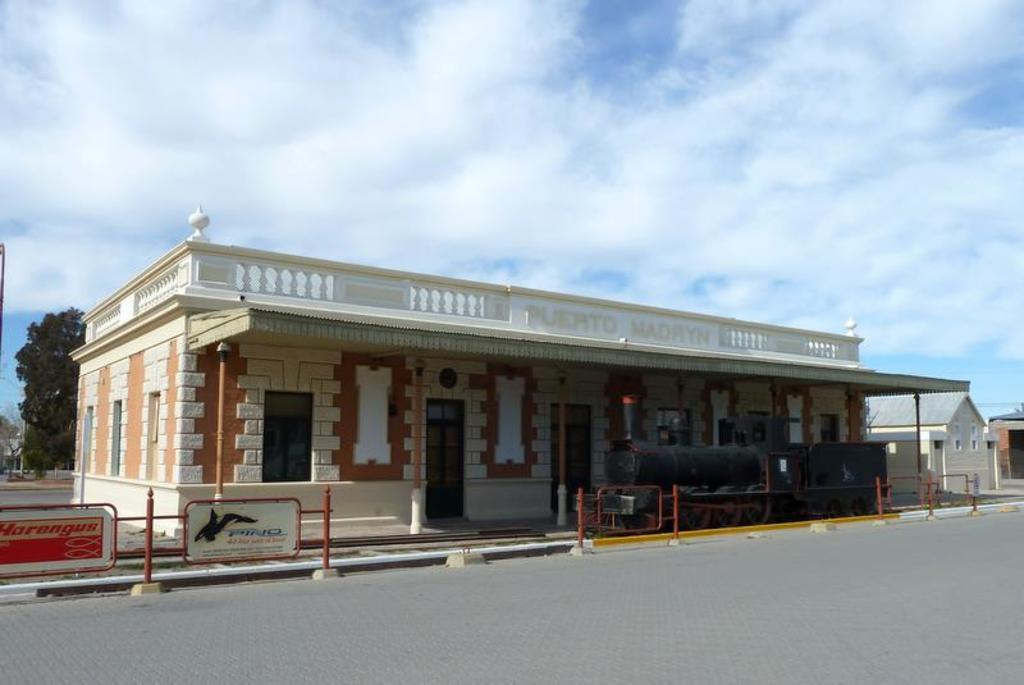What type of structures can be seen in the image? There are houses in the image. What is located in front of the houses? There is a road and a fence in front of the houses. What can be seen behind the houses? There are trees visible behind the houses. How many rabbits can be seen playing with an orange on the road in the image? There are no rabbits or oranges present in the image; it only features houses, a road, a fence, and trees. 